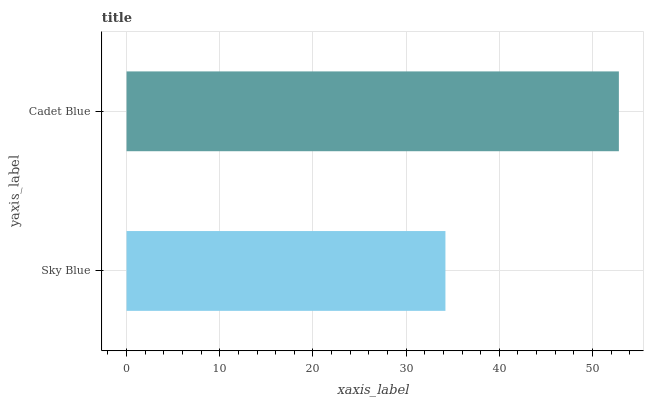Is Sky Blue the minimum?
Answer yes or no. Yes. Is Cadet Blue the maximum?
Answer yes or no. Yes. Is Cadet Blue the minimum?
Answer yes or no. No. Is Cadet Blue greater than Sky Blue?
Answer yes or no. Yes. Is Sky Blue less than Cadet Blue?
Answer yes or no. Yes. Is Sky Blue greater than Cadet Blue?
Answer yes or no. No. Is Cadet Blue less than Sky Blue?
Answer yes or no. No. Is Cadet Blue the high median?
Answer yes or no. Yes. Is Sky Blue the low median?
Answer yes or no. Yes. Is Sky Blue the high median?
Answer yes or no. No. Is Cadet Blue the low median?
Answer yes or no. No. 